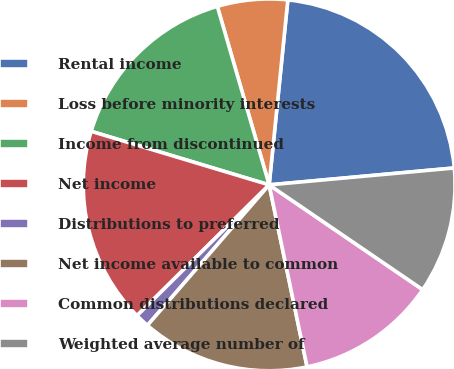Convert chart to OTSL. <chart><loc_0><loc_0><loc_500><loc_500><pie_chart><fcel>Rental income<fcel>Loss before minority interests<fcel>Income from discontinued<fcel>Net income<fcel>Distributions to preferred<fcel>Net income available to common<fcel>Common distributions declared<fcel>Weighted average number of<nl><fcel>21.95%<fcel>6.1%<fcel>15.85%<fcel>17.07%<fcel>1.22%<fcel>14.63%<fcel>12.2%<fcel>10.98%<nl></chart> 